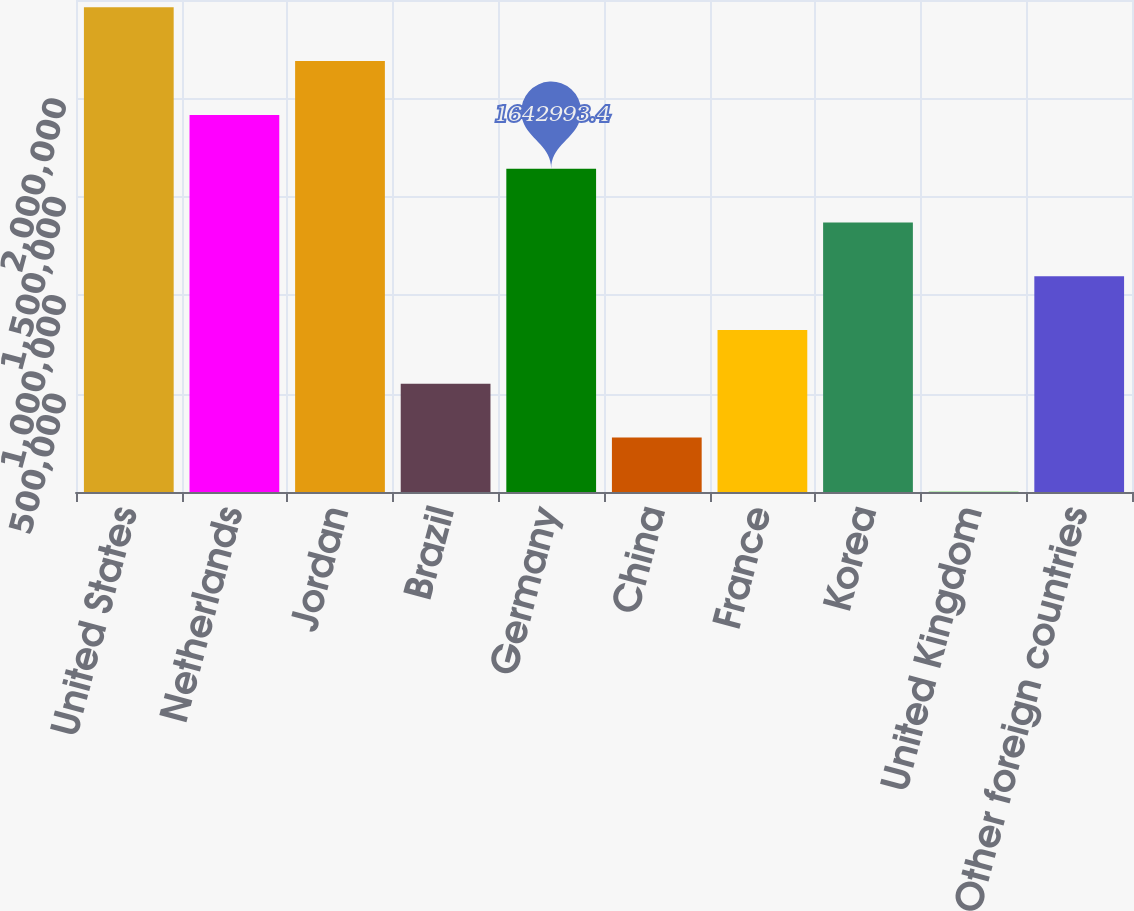Convert chart. <chart><loc_0><loc_0><loc_500><loc_500><bar_chart><fcel>United States<fcel>Netherlands<fcel>Jordan<fcel>Brazil<fcel>Germany<fcel>China<fcel>France<fcel>Korea<fcel>United Kingdom<fcel>Other foreign countries<nl><fcel>2.46266e+06<fcel>1.91621e+06<fcel>2.18944e+06<fcel>550108<fcel>1.64299e+06<fcel>276886<fcel>823329<fcel>1.36977e+06<fcel>3665<fcel>1.09655e+06<nl></chart> 